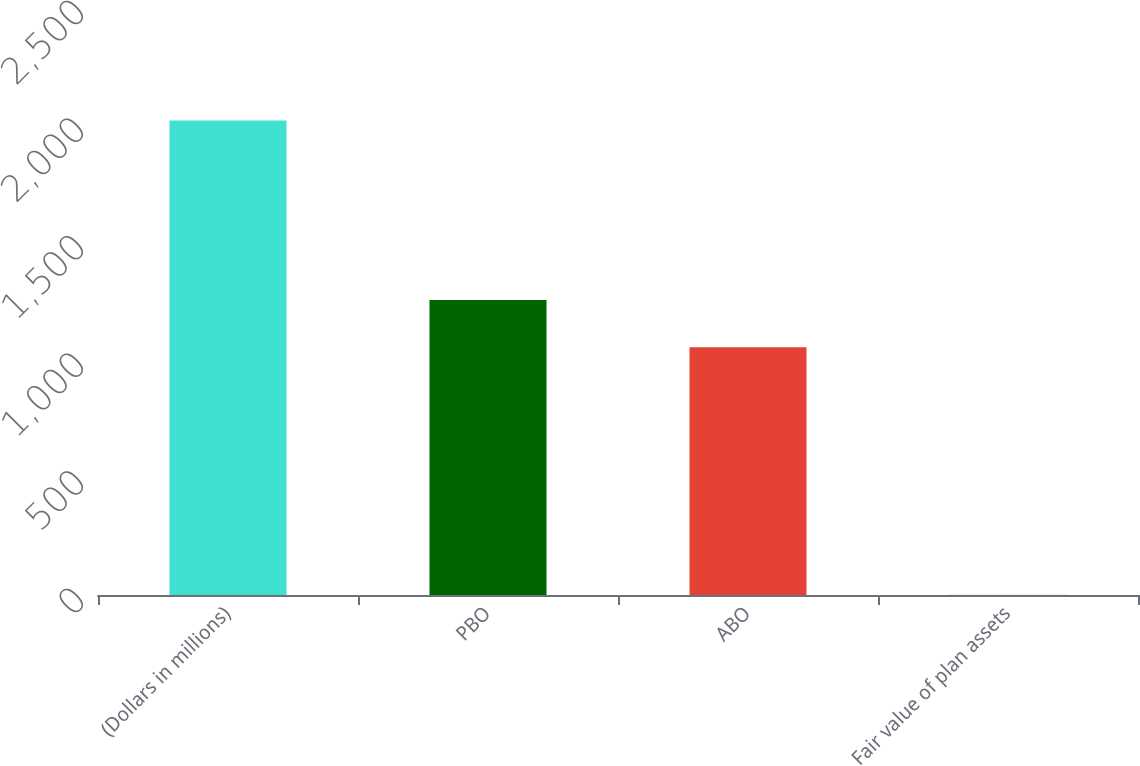Convert chart to OTSL. <chart><loc_0><loc_0><loc_500><loc_500><bar_chart><fcel>(Dollars in millions)<fcel>PBO<fcel>ABO<fcel>Fair value of plan assets<nl><fcel>2017<fcel>1254.6<fcel>1053<fcel>1<nl></chart> 